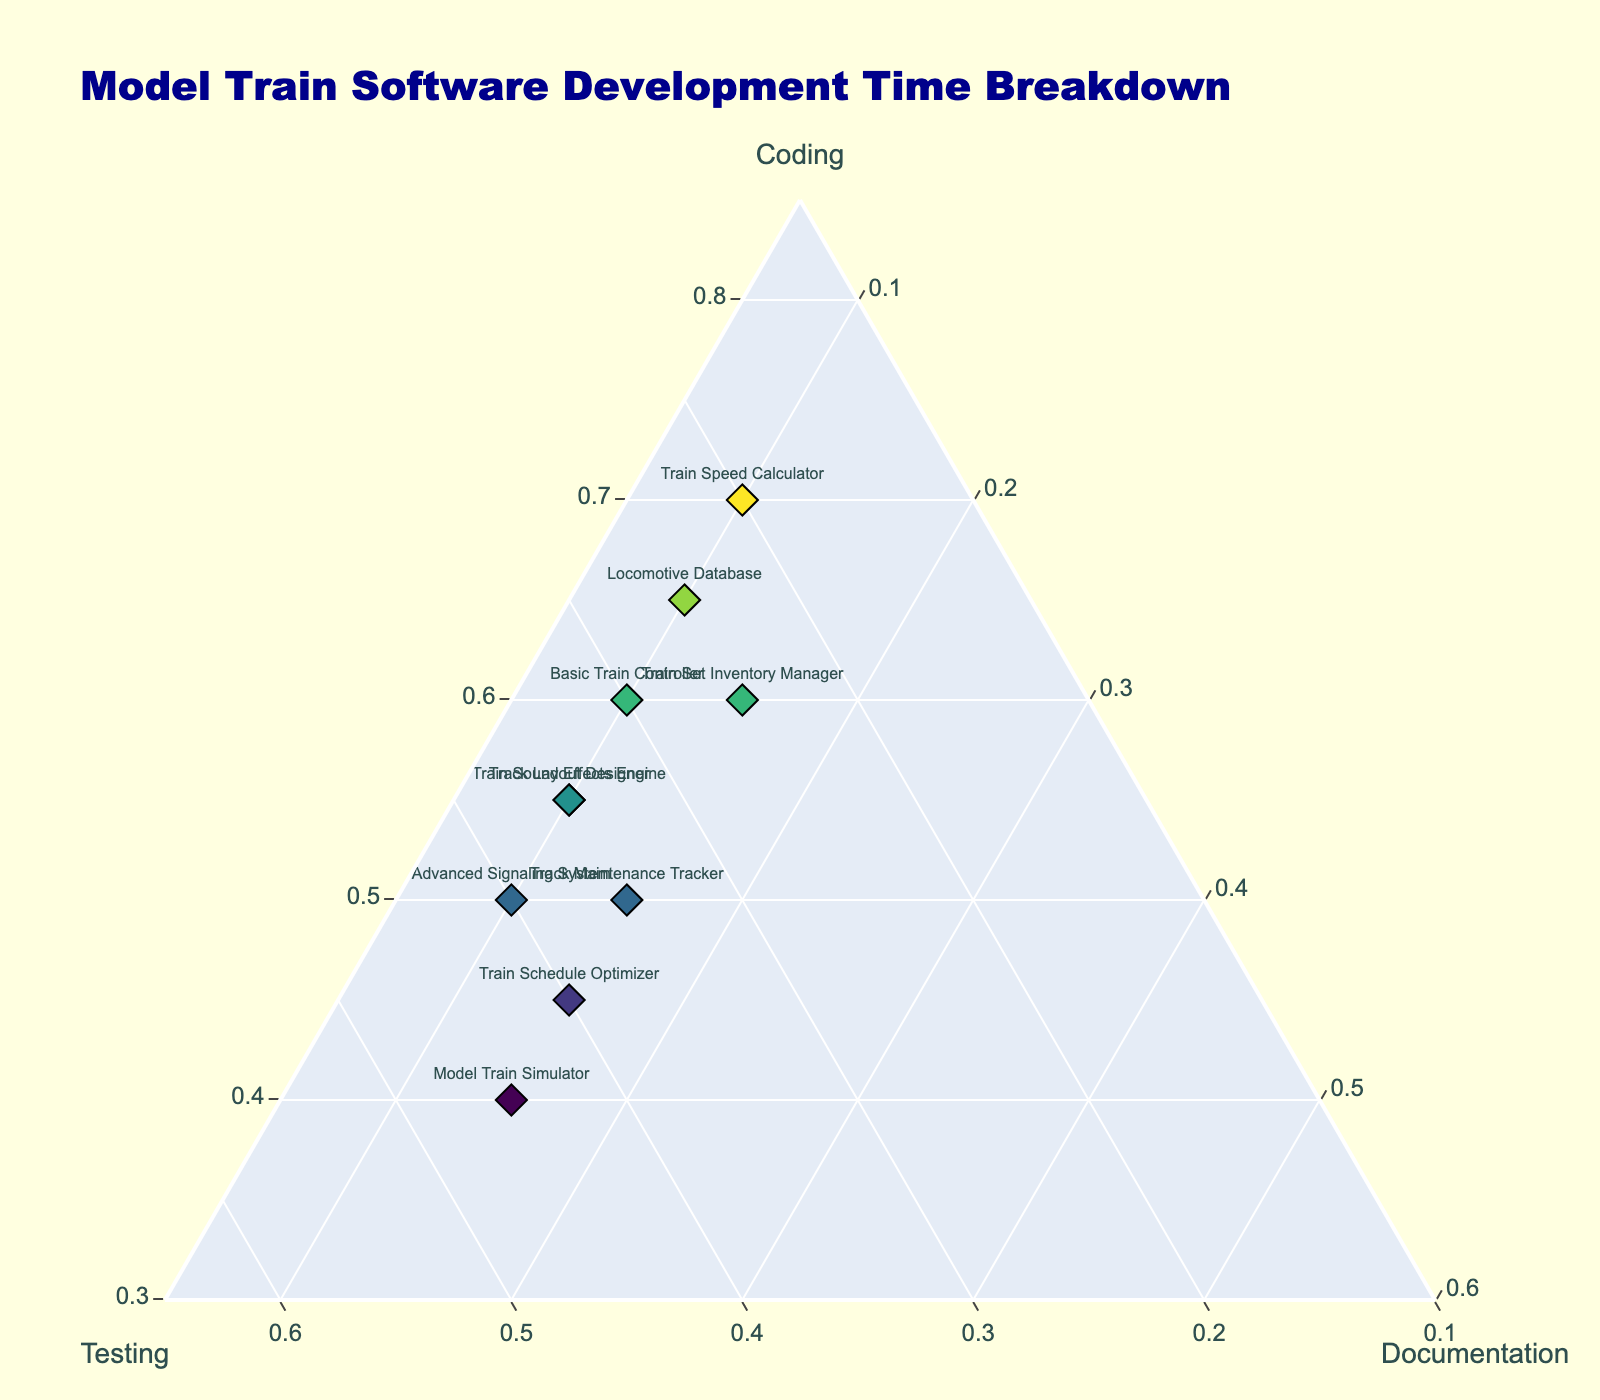What is the title of the figure? The title of the figure is located at the top and typically provides a brief summary of what the data represents. In this case, the title reads "Model Train Software Development Time Breakdown".
Answer: Model Train Software Development Time Breakdown How are the axes labeled? Each axis on a ternary plot represents one of the three variables. In this figure, the labels are "Coding" for one axis, "Testing" for another, and "Documentation" for the third.
Answer: Coding, Testing, Documentation Which project spends the most time on Coding? To determine this, look for the data point that is positioned closest to the "Coding" axis. The "Train Speed Calculator" has the highest percentage on the Coding axis, making it the project that spends the most time on Coding.
Answer: Train Speed Calculator What percentage of time is spent on Documentation for the "Train Schedule Optimizer" project? Since each project’s data point is annotated, find the label "Train Schedule Optimizer". Its position should show a lower value on the Documentation axis. For it, the time spent on Documentation is 15%.
Answer: 15% Which project has an equal percentage of time spent on Testing and Documentation? Look for a data point equidistant from the Testing and Documentation axes. From the figure, "Train Schedule Optimizer" stands out as having equal percentages of Testing and Documentation, both at 15%.
Answer: Train Schedule Optimizer Among the projects that spend between 50% and 60% of their time on Coding, which one spends the least time on Testing? The projects spending between 50% and 60% of their time on Coding are "Train Set Inventory Manager" (60%), "Track Layout Designer" (55%), "Train Sound Effects Engine" (55%), and "Advanced Signaling System" (50%). Among them, "Train Set Inventory Manager" spends 25% of time on Testing, which is the least.
Answer: Train Set Inventory Manager What is the sum of the time spent on Coding for "Basic Train Controller" and "Locomotive Database"? For "Basic Train Controller", the time spent on Coding is 60%. For "Locomotive Database", it is 65%. Summing these, 60% + 65% = 125%.
Answer: 125% Does any project spend more time on Documentation than on Testing? By comparing the Documentation and Testing percentages for each project, it is observed that none of the projects spend more time on Documentation than on Testing.
Answer: No Which project has a balanced breakdown with the least time disparity across the three aspects? A balanced breakdown would be a point relatively close to the center of the plot. "Model Train Simulator" seems to have a balanced time allocation with Coding (40%), Testing (45%), and Documentation (15%).
Answer: Model Train Simulator 